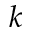Convert formula to latex. <formula><loc_0><loc_0><loc_500><loc_500>k</formula> 